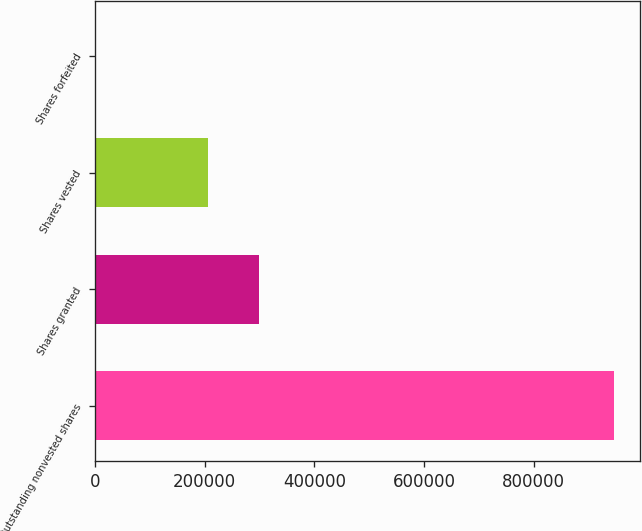<chart> <loc_0><loc_0><loc_500><loc_500><bar_chart><fcel>Outstanding nonvested shares<fcel>Shares granted<fcel>Shares vested<fcel>Shares forfeited<nl><fcel>945565<fcel>298484<fcel>206153<fcel>987<nl></chart> 